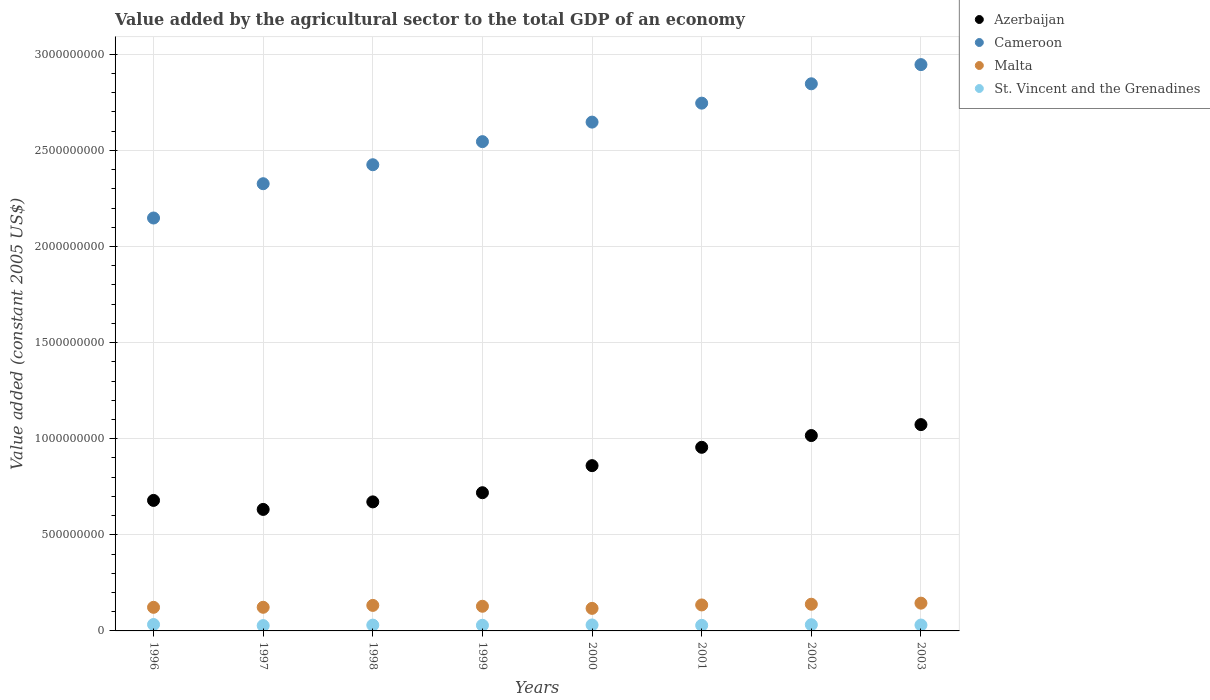How many different coloured dotlines are there?
Offer a terse response. 4. What is the value added by the agricultural sector in Cameroon in 2003?
Your answer should be very brief. 2.95e+09. Across all years, what is the maximum value added by the agricultural sector in Cameroon?
Your response must be concise. 2.95e+09. Across all years, what is the minimum value added by the agricultural sector in Azerbaijan?
Keep it short and to the point. 6.32e+08. In which year was the value added by the agricultural sector in St. Vincent and the Grenadines maximum?
Keep it short and to the point. 1996. In which year was the value added by the agricultural sector in Azerbaijan minimum?
Your answer should be very brief. 1997. What is the total value added by the agricultural sector in Azerbaijan in the graph?
Keep it short and to the point. 6.61e+09. What is the difference between the value added by the agricultural sector in St. Vincent and the Grenadines in 1999 and that in 2002?
Give a very brief answer. -2.91e+06. What is the difference between the value added by the agricultural sector in St. Vincent and the Grenadines in 2002 and the value added by the agricultural sector in Malta in 2003?
Ensure brevity in your answer.  -1.12e+08. What is the average value added by the agricultural sector in Azerbaijan per year?
Provide a succinct answer. 8.26e+08. In the year 1999, what is the difference between the value added by the agricultural sector in Cameroon and value added by the agricultural sector in St. Vincent and the Grenadines?
Offer a terse response. 2.52e+09. In how many years, is the value added by the agricultural sector in Malta greater than 900000000 US$?
Give a very brief answer. 0. What is the ratio of the value added by the agricultural sector in St. Vincent and the Grenadines in 1996 to that in 1999?
Your answer should be very brief. 1.14. Is the value added by the agricultural sector in Azerbaijan in 1998 less than that in 1999?
Make the answer very short. Yes. What is the difference between the highest and the second highest value added by the agricultural sector in Cameroon?
Your response must be concise. 9.97e+07. What is the difference between the highest and the lowest value added by the agricultural sector in Malta?
Ensure brevity in your answer.  2.71e+07. In how many years, is the value added by the agricultural sector in St. Vincent and the Grenadines greater than the average value added by the agricultural sector in St. Vincent and the Grenadines taken over all years?
Provide a succinct answer. 4. Is the sum of the value added by the agricultural sector in Cameroon in 1997 and 2001 greater than the maximum value added by the agricultural sector in Azerbaijan across all years?
Provide a succinct answer. Yes. Is it the case that in every year, the sum of the value added by the agricultural sector in St. Vincent and the Grenadines and value added by the agricultural sector in Malta  is greater than the value added by the agricultural sector in Azerbaijan?
Your answer should be compact. No. Does the value added by the agricultural sector in Cameroon monotonically increase over the years?
Ensure brevity in your answer.  Yes. Is the value added by the agricultural sector in St. Vincent and the Grenadines strictly greater than the value added by the agricultural sector in Azerbaijan over the years?
Provide a succinct answer. No. What is the difference between two consecutive major ticks on the Y-axis?
Offer a very short reply. 5.00e+08. Are the values on the major ticks of Y-axis written in scientific E-notation?
Offer a terse response. No. Does the graph contain any zero values?
Your answer should be very brief. No. Where does the legend appear in the graph?
Offer a terse response. Top right. What is the title of the graph?
Provide a short and direct response. Value added by the agricultural sector to the total GDP of an economy. What is the label or title of the Y-axis?
Your answer should be very brief. Value added (constant 2005 US$). What is the Value added (constant 2005 US$) in Azerbaijan in 1996?
Make the answer very short. 6.79e+08. What is the Value added (constant 2005 US$) in Cameroon in 1996?
Keep it short and to the point. 2.15e+09. What is the Value added (constant 2005 US$) in Malta in 1996?
Ensure brevity in your answer.  1.23e+08. What is the Value added (constant 2005 US$) in St. Vincent and the Grenadines in 1996?
Make the answer very short. 3.33e+07. What is the Value added (constant 2005 US$) of Azerbaijan in 1997?
Your answer should be compact. 6.32e+08. What is the Value added (constant 2005 US$) of Cameroon in 1997?
Provide a succinct answer. 2.33e+09. What is the Value added (constant 2005 US$) of Malta in 1997?
Provide a short and direct response. 1.23e+08. What is the Value added (constant 2005 US$) in St. Vincent and the Grenadines in 1997?
Keep it short and to the point. 2.77e+07. What is the Value added (constant 2005 US$) of Azerbaijan in 1998?
Ensure brevity in your answer.  6.71e+08. What is the Value added (constant 2005 US$) of Cameroon in 1998?
Your response must be concise. 2.43e+09. What is the Value added (constant 2005 US$) in Malta in 1998?
Give a very brief answer. 1.33e+08. What is the Value added (constant 2005 US$) in St. Vincent and the Grenadines in 1998?
Ensure brevity in your answer.  3.02e+07. What is the Value added (constant 2005 US$) of Azerbaijan in 1999?
Provide a succinct answer. 7.19e+08. What is the Value added (constant 2005 US$) of Cameroon in 1999?
Your response must be concise. 2.55e+09. What is the Value added (constant 2005 US$) in Malta in 1999?
Keep it short and to the point. 1.28e+08. What is the Value added (constant 2005 US$) of St. Vincent and the Grenadines in 1999?
Your answer should be very brief. 2.94e+07. What is the Value added (constant 2005 US$) in Azerbaijan in 2000?
Give a very brief answer. 8.60e+08. What is the Value added (constant 2005 US$) of Cameroon in 2000?
Offer a very short reply. 2.65e+09. What is the Value added (constant 2005 US$) of Malta in 2000?
Keep it short and to the point. 1.17e+08. What is the Value added (constant 2005 US$) of St. Vincent and the Grenadines in 2000?
Your answer should be very brief. 3.10e+07. What is the Value added (constant 2005 US$) of Azerbaijan in 2001?
Your answer should be very brief. 9.55e+08. What is the Value added (constant 2005 US$) of Cameroon in 2001?
Make the answer very short. 2.75e+09. What is the Value added (constant 2005 US$) in Malta in 2001?
Provide a succinct answer. 1.35e+08. What is the Value added (constant 2005 US$) of St. Vincent and the Grenadines in 2001?
Your answer should be compact. 2.89e+07. What is the Value added (constant 2005 US$) in Azerbaijan in 2002?
Provide a succinct answer. 1.02e+09. What is the Value added (constant 2005 US$) in Cameroon in 2002?
Provide a short and direct response. 2.85e+09. What is the Value added (constant 2005 US$) in Malta in 2002?
Your answer should be compact. 1.39e+08. What is the Value added (constant 2005 US$) in St. Vincent and the Grenadines in 2002?
Give a very brief answer. 3.23e+07. What is the Value added (constant 2005 US$) of Azerbaijan in 2003?
Provide a short and direct response. 1.07e+09. What is the Value added (constant 2005 US$) of Cameroon in 2003?
Ensure brevity in your answer.  2.95e+09. What is the Value added (constant 2005 US$) of Malta in 2003?
Provide a succinct answer. 1.44e+08. What is the Value added (constant 2005 US$) in St. Vincent and the Grenadines in 2003?
Your answer should be very brief. 3.06e+07. Across all years, what is the maximum Value added (constant 2005 US$) of Azerbaijan?
Ensure brevity in your answer.  1.07e+09. Across all years, what is the maximum Value added (constant 2005 US$) of Cameroon?
Your answer should be very brief. 2.95e+09. Across all years, what is the maximum Value added (constant 2005 US$) of Malta?
Ensure brevity in your answer.  1.44e+08. Across all years, what is the maximum Value added (constant 2005 US$) of St. Vincent and the Grenadines?
Provide a short and direct response. 3.33e+07. Across all years, what is the minimum Value added (constant 2005 US$) of Azerbaijan?
Keep it short and to the point. 6.32e+08. Across all years, what is the minimum Value added (constant 2005 US$) of Cameroon?
Your response must be concise. 2.15e+09. Across all years, what is the minimum Value added (constant 2005 US$) in Malta?
Your response must be concise. 1.17e+08. Across all years, what is the minimum Value added (constant 2005 US$) in St. Vincent and the Grenadines?
Your answer should be very brief. 2.77e+07. What is the total Value added (constant 2005 US$) of Azerbaijan in the graph?
Make the answer very short. 6.61e+09. What is the total Value added (constant 2005 US$) in Cameroon in the graph?
Offer a very short reply. 2.06e+1. What is the total Value added (constant 2005 US$) in Malta in the graph?
Offer a very short reply. 1.04e+09. What is the total Value added (constant 2005 US$) of St. Vincent and the Grenadines in the graph?
Make the answer very short. 2.43e+08. What is the difference between the Value added (constant 2005 US$) of Azerbaijan in 1996 and that in 1997?
Your response must be concise. 4.69e+07. What is the difference between the Value added (constant 2005 US$) of Cameroon in 1996 and that in 1997?
Your answer should be very brief. -1.78e+08. What is the difference between the Value added (constant 2005 US$) in Malta in 1996 and that in 1997?
Offer a terse response. -2.32e+05. What is the difference between the Value added (constant 2005 US$) of St. Vincent and the Grenadines in 1996 and that in 1997?
Offer a terse response. 5.68e+06. What is the difference between the Value added (constant 2005 US$) of Azerbaijan in 1996 and that in 1998?
Offer a very short reply. 7.66e+06. What is the difference between the Value added (constant 2005 US$) of Cameroon in 1996 and that in 1998?
Offer a very short reply. -2.77e+08. What is the difference between the Value added (constant 2005 US$) of Malta in 1996 and that in 1998?
Your answer should be compact. -1.00e+07. What is the difference between the Value added (constant 2005 US$) in St. Vincent and the Grenadines in 1996 and that in 1998?
Provide a succinct answer. 3.18e+06. What is the difference between the Value added (constant 2005 US$) of Azerbaijan in 1996 and that in 1999?
Keep it short and to the point. -4.00e+07. What is the difference between the Value added (constant 2005 US$) in Cameroon in 1996 and that in 1999?
Make the answer very short. -3.97e+08. What is the difference between the Value added (constant 2005 US$) in Malta in 1996 and that in 1999?
Keep it short and to the point. -5.55e+06. What is the difference between the Value added (constant 2005 US$) of St. Vincent and the Grenadines in 1996 and that in 1999?
Provide a short and direct response. 3.99e+06. What is the difference between the Value added (constant 2005 US$) of Azerbaijan in 1996 and that in 2000?
Make the answer very short. -1.81e+08. What is the difference between the Value added (constant 2005 US$) of Cameroon in 1996 and that in 2000?
Give a very brief answer. -4.99e+08. What is the difference between the Value added (constant 2005 US$) of Malta in 1996 and that in 2000?
Offer a very short reply. 5.41e+06. What is the difference between the Value added (constant 2005 US$) in St. Vincent and the Grenadines in 1996 and that in 2000?
Provide a short and direct response. 2.29e+06. What is the difference between the Value added (constant 2005 US$) in Azerbaijan in 1996 and that in 2001?
Provide a succinct answer. -2.76e+08. What is the difference between the Value added (constant 2005 US$) of Cameroon in 1996 and that in 2001?
Your answer should be compact. -5.98e+08. What is the difference between the Value added (constant 2005 US$) of Malta in 1996 and that in 2001?
Your answer should be compact. -1.24e+07. What is the difference between the Value added (constant 2005 US$) in St. Vincent and the Grenadines in 1996 and that in 2001?
Provide a short and direct response. 4.41e+06. What is the difference between the Value added (constant 2005 US$) of Azerbaijan in 1996 and that in 2002?
Provide a succinct answer. -3.37e+08. What is the difference between the Value added (constant 2005 US$) of Cameroon in 1996 and that in 2002?
Make the answer very short. -6.98e+08. What is the difference between the Value added (constant 2005 US$) in Malta in 1996 and that in 2002?
Provide a succinct answer. -1.61e+07. What is the difference between the Value added (constant 2005 US$) of St. Vincent and the Grenadines in 1996 and that in 2002?
Ensure brevity in your answer.  1.08e+06. What is the difference between the Value added (constant 2005 US$) of Azerbaijan in 1996 and that in 2003?
Your answer should be compact. -3.94e+08. What is the difference between the Value added (constant 2005 US$) in Cameroon in 1996 and that in 2003?
Ensure brevity in your answer.  -7.98e+08. What is the difference between the Value added (constant 2005 US$) of Malta in 1996 and that in 2003?
Offer a very short reply. -2.17e+07. What is the difference between the Value added (constant 2005 US$) of St. Vincent and the Grenadines in 1996 and that in 2003?
Your response must be concise. 2.71e+06. What is the difference between the Value added (constant 2005 US$) in Azerbaijan in 1997 and that in 1998?
Offer a very short reply. -3.92e+07. What is the difference between the Value added (constant 2005 US$) of Cameroon in 1997 and that in 1998?
Provide a short and direct response. -9.88e+07. What is the difference between the Value added (constant 2005 US$) in Malta in 1997 and that in 1998?
Give a very brief answer. -9.79e+06. What is the difference between the Value added (constant 2005 US$) in St. Vincent and the Grenadines in 1997 and that in 1998?
Give a very brief answer. -2.50e+06. What is the difference between the Value added (constant 2005 US$) of Azerbaijan in 1997 and that in 1999?
Your response must be concise. -8.69e+07. What is the difference between the Value added (constant 2005 US$) of Cameroon in 1997 and that in 1999?
Provide a succinct answer. -2.19e+08. What is the difference between the Value added (constant 2005 US$) in Malta in 1997 and that in 1999?
Your answer should be compact. -5.32e+06. What is the difference between the Value added (constant 2005 US$) of St. Vincent and the Grenadines in 1997 and that in 1999?
Make the answer very short. -1.69e+06. What is the difference between the Value added (constant 2005 US$) of Azerbaijan in 1997 and that in 2000?
Keep it short and to the point. -2.28e+08. What is the difference between the Value added (constant 2005 US$) in Cameroon in 1997 and that in 2000?
Provide a succinct answer. -3.21e+08. What is the difference between the Value added (constant 2005 US$) in Malta in 1997 and that in 2000?
Give a very brief answer. 5.64e+06. What is the difference between the Value added (constant 2005 US$) of St. Vincent and the Grenadines in 1997 and that in 2000?
Give a very brief answer. -3.38e+06. What is the difference between the Value added (constant 2005 US$) in Azerbaijan in 1997 and that in 2001?
Offer a very short reply. -3.23e+08. What is the difference between the Value added (constant 2005 US$) of Cameroon in 1997 and that in 2001?
Your answer should be compact. -4.19e+08. What is the difference between the Value added (constant 2005 US$) in Malta in 1997 and that in 2001?
Your answer should be very brief. -1.22e+07. What is the difference between the Value added (constant 2005 US$) of St. Vincent and the Grenadines in 1997 and that in 2001?
Provide a succinct answer. -1.27e+06. What is the difference between the Value added (constant 2005 US$) of Azerbaijan in 1997 and that in 2002?
Your answer should be compact. -3.84e+08. What is the difference between the Value added (constant 2005 US$) of Cameroon in 1997 and that in 2002?
Offer a terse response. -5.20e+08. What is the difference between the Value added (constant 2005 US$) in Malta in 1997 and that in 2002?
Your answer should be very brief. -1.59e+07. What is the difference between the Value added (constant 2005 US$) of St. Vincent and the Grenadines in 1997 and that in 2002?
Provide a short and direct response. -4.60e+06. What is the difference between the Value added (constant 2005 US$) of Azerbaijan in 1997 and that in 2003?
Keep it short and to the point. -4.41e+08. What is the difference between the Value added (constant 2005 US$) of Cameroon in 1997 and that in 2003?
Give a very brief answer. -6.20e+08. What is the difference between the Value added (constant 2005 US$) of Malta in 1997 and that in 2003?
Keep it short and to the point. -2.15e+07. What is the difference between the Value added (constant 2005 US$) in St. Vincent and the Grenadines in 1997 and that in 2003?
Your answer should be compact. -2.97e+06. What is the difference between the Value added (constant 2005 US$) in Azerbaijan in 1998 and that in 1999?
Keep it short and to the point. -4.77e+07. What is the difference between the Value added (constant 2005 US$) in Cameroon in 1998 and that in 1999?
Your answer should be compact. -1.20e+08. What is the difference between the Value added (constant 2005 US$) of Malta in 1998 and that in 1999?
Your answer should be very brief. 4.47e+06. What is the difference between the Value added (constant 2005 US$) of St. Vincent and the Grenadines in 1998 and that in 1999?
Keep it short and to the point. 8.10e+05. What is the difference between the Value added (constant 2005 US$) of Azerbaijan in 1998 and that in 2000?
Your answer should be very brief. -1.89e+08. What is the difference between the Value added (constant 2005 US$) in Cameroon in 1998 and that in 2000?
Ensure brevity in your answer.  -2.22e+08. What is the difference between the Value added (constant 2005 US$) in Malta in 1998 and that in 2000?
Make the answer very short. 1.54e+07. What is the difference between the Value added (constant 2005 US$) of St. Vincent and the Grenadines in 1998 and that in 2000?
Your answer should be compact. -8.86e+05. What is the difference between the Value added (constant 2005 US$) in Azerbaijan in 1998 and that in 2001?
Your answer should be very brief. -2.84e+08. What is the difference between the Value added (constant 2005 US$) of Cameroon in 1998 and that in 2001?
Keep it short and to the point. -3.20e+08. What is the difference between the Value added (constant 2005 US$) of Malta in 1998 and that in 2001?
Provide a short and direct response. -2.40e+06. What is the difference between the Value added (constant 2005 US$) in St. Vincent and the Grenadines in 1998 and that in 2001?
Keep it short and to the point. 1.23e+06. What is the difference between the Value added (constant 2005 US$) of Azerbaijan in 1998 and that in 2002?
Ensure brevity in your answer.  -3.45e+08. What is the difference between the Value added (constant 2005 US$) of Cameroon in 1998 and that in 2002?
Give a very brief answer. -4.21e+08. What is the difference between the Value added (constant 2005 US$) of Malta in 1998 and that in 2002?
Give a very brief answer. -6.11e+06. What is the difference between the Value added (constant 2005 US$) in St. Vincent and the Grenadines in 1998 and that in 2002?
Your response must be concise. -2.10e+06. What is the difference between the Value added (constant 2005 US$) in Azerbaijan in 1998 and that in 2003?
Provide a short and direct response. -4.02e+08. What is the difference between the Value added (constant 2005 US$) in Cameroon in 1998 and that in 2003?
Your response must be concise. -5.21e+08. What is the difference between the Value added (constant 2005 US$) of Malta in 1998 and that in 2003?
Keep it short and to the point. -1.17e+07. What is the difference between the Value added (constant 2005 US$) of St. Vincent and the Grenadines in 1998 and that in 2003?
Your answer should be very brief. -4.70e+05. What is the difference between the Value added (constant 2005 US$) in Azerbaijan in 1999 and that in 2000?
Offer a very short reply. -1.41e+08. What is the difference between the Value added (constant 2005 US$) of Cameroon in 1999 and that in 2000?
Make the answer very short. -1.02e+08. What is the difference between the Value added (constant 2005 US$) of Malta in 1999 and that in 2000?
Provide a succinct answer. 1.10e+07. What is the difference between the Value added (constant 2005 US$) of St. Vincent and the Grenadines in 1999 and that in 2000?
Your answer should be compact. -1.70e+06. What is the difference between the Value added (constant 2005 US$) in Azerbaijan in 1999 and that in 2001?
Give a very brief answer. -2.36e+08. What is the difference between the Value added (constant 2005 US$) of Cameroon in 1999 and that in 2001?
Keep it short and to the point. -2.00e+08. What is the difference between the Value added (constant 2005 US$) in Malta in 1999 and that in 2001?
Your response must be concise. -6.88e+06. What is the difference between the Value added (constant 2005 US$) of St. Vincent and the Grenadines in 1999 and that in 2001?
Your answer should be compact. 4.23e+05. What is the difference between the Value added (constant 2005 US$) in Azerbaijan in 1999 and that in 2002?
Make the answer very short. -2.97e+08. What is the difference between the Value added (constant 2005 US$) in Cameroon in 1999 and that in 2002?
Make the answer very short. -3.01e+08. What is the difference between the Value added (constant 2005 US$) of Malta in 1999 and that in 2002?
Your answer should be very brief. -1.06e+07. What is the difference between the Value added (constant 2005 US$) in St. Vincent and the Grenadines in 1999 and that in 2002?
Keep it short and to the point. -2.91e+06. What is the difference between the Value added (constant 2005 US$) in Azerbaijan in 1999 and that in 2003?
Provide a short and direct response. -3.54e+08. What is the difference between the Value added (constant 2005 US$) of Cameroon in 1999 and that in 2003?
Ensure brevity in your answer.  -4.01e+08. What is the difference between the Value added (constant 2005 US$) of Malta in 1999 and that in 2003?
Offer a terse response. -1.62e+07. What is the difference between the Value added (constant 2005 US$) of St. Vincent and the Grenadines in 1999 and that in 2003?
Your answer should be compact. -1.28e+06. What is the difference between the Value added (constant 2005 US$) in Azerbaijan in 2000 and that in 2001?
Your answer should be compact. -9.54e+07. What is the difference between the Value added (constant 2005 US$) in Cameroon in 2000 and that in 2001?
Keep it short and to the point. -9.86e+07. What is the difference between the Value added (constant 2005 US$) in Malta in 2000 and that in 2001?
Your response must be concise. -1.78e+07. What is the difference between the Value added (constant 2005 US$) of St. Vincent and the Grenadines in 2000 and that in 2001?
Provide a succinct answer. 2.12e+06. What is the difference between the Value added (constant 2005 US$) of Azerbaijan in 2000 and that in 2002?
Ensure brevity in your answer.  -1.57e+08. What is the difference between the Value added (constant 2005 US$) in Cameroon in 2000 and that in 2002?
Keep it short and to the point. -1.99e+08. What is the difference between the Value added (constant 2005 US$) of Malta in 2000 and that in 2002?
Provide a short and direct response. -2.15e+07. What is the difference between the Value added (constant 2005 US$) of St. Vincent and the Grenadines in 2000 and that in 2002?
Your answer should be compact. -1.21e+06. What is the difference between the Value added (constant 2005 US$) of Azerbaijan in 2000 and that in 2003?
Provide a succinct answer. -2.14e+08. What is the difference between the Value added (constant 2005 US$) in Cameroon in 2000 and that in 2003?
Your answer should be very brief. -2.99e+08. What is the difference between the Value added (constant 2005 US$) in Malta in 2000 and that in 2003?
Provide a short and direct response. -2.71e+07. What is the difference between the Value added (constant 2005 US$) in St. Vincent and the Grenadines in 2000 and that in 2003?
Your response must be concise. 4.16e+05. What is the difference between the Value added (constant 2005 US$) in Azerbaijan in 2001 and that in 2002?
Provide a succinct answer. -6.11e+07. What is the difference between the Value added (constant 2005 US$) of Cameroon in 2001 and that in 2002?
Your answer should be compact. -1.01e+08. What is the difference between the Value added (constant 2005 US$) in Malta in 2001 and that in 2002?
Provide a short and direct response. -3.71e+06. What is the difference between the Value added (constant 2005 US$) in St. Vincent and the Grenadines in 2001 and that in 2002?
Make the answer very short. -3.33e+06. What is the difference between the Value added (constant 2005 US$) in Azerbaijan in 2001 and that in 2003?
Give a very brief answer. -1.18e+08. What is the difference between the Value added (constant 2005 US$) in Cameroon in 2001 and that in 2003?
Offer a terse response. -2.00e+08. What is the difference between the Value added (constant 2005 US$) of Malta in 2001 and that in 2003?
Provide a short and direct response. -9.29e+06. What is the difference between the Value added (constant 2005 US$) in St. Vincent and the Grenadines in 2001 and that in 2003?
Your response must be concise. -1.70e+06. What is the difference between the Value added (constant 2005 US$) of Azerbaijan in 2002 and that in 2003?
Offer a very short reply. -5.69e+07. What is the difference between the Value added (constant 2005 US$) in Cameroon in 2002 and that in 2003?
Provide a succinct answer. -9.97e+07. What is the difference between the Value added (constant 2005 US$) in Malta in 2002 and that in 2003?
Offer a very short reply. -5.59e+06. What is the difference between the Value added (constant 2005 US$) of St. Vincent and the Grenadines in 2002 and that in 2003?
Ensure brevity in your answer.  1.63e+06. What is the difference between the Value added (constant 2005 US$) in Azerbaijan in 1996 and the Value added (constant 2005 US$) in Cameroon in 1997?
Offer a terse response. -1.65e+09. What is the difference between the Value added (constant 2005 US$) in Azerbaijan in 1996 and the Value added (constant 2005 US$) in Malta in 1997?
Offer a terse response. 5.56e+08. What is the difference between the Value added (constant 2005 US$) of Azerbaijan in 1996 and the Value added (constant 2005 US$) of St. Vincent and the Grenadines in 1997?
Make the answer very short. 6.51e+08. What is the difference between the Value added (constant 2005 US$) in Cameroon in 1996 and the Value added (constant 2005 US$) in Malta in 1997?
Provide a succinct answer. 2.03e+09. What is the difference between the Value added (constant 2005 US$) of Cameroon in 1996 and the Value added (constant 2005 US$) of St. Vincent and the Grenadines in 1997?
Your answer should be very brief. 2.12e+09. What is the difference between the Value added (constant 2005 US$) of Malta in 1996 and the Value added (constant 2005 US$) of St. Vincent and the Grenadines in 1997?
Ensure brevity in your answer.  9.51e+07. What is the difference between the Value added (constant 2005 US$) of Azerbaijan in 1996 and the Value added (constant 2005 US$) of Cameroon in 1998?
Offer a very short reply. -1.75e+09. What is the difference between the Value added (constant 2005 US$) of Azerbaijan in 1996 and the Value added (constant 2005 US$) of Malta in 1998?
Offer a very short reply. 5.46e+08. What is the difference between the Value added (constant 2005 US$) of Azerbaijan in 1996 and the Value added (constant 2005 US$) of St. Vincent and the Grenadines in 1998?
Ensure brevity in your answer.  6.49e+08. What is the difference between the Value added (constant 2005 US$) of Cameroon in 1996 and the Value added (constant 2005 US$) of Malta in 1998?
Offer a terse response. 2.02e+09. What is the difference between the Value added (constant 2005 US$) of Cameroon in 1996 and the Value added (constant 2005 US$) of St. Vincent and the Grenadines in 1998?
Provide a succinct answer. 2.12e+09. What is the difference between the Value added (constant 2005 US$) in Malta in 1996 and the Value added (constant 2005 US$) in St. Vincent and the Grenadines in 1998?
Provide a succinct answer. 9.26e+07. What is the difference between the Value added (constant 2005 US$) in Azerbaijan in 1996 and the Value added (constant 2005 US$) in Cameroon in 1999?
Offer a terse response. -1.87e+09. What is the difference between the Value added (constant 2005 US$) of Azerbaijan in 1996 and the Value added (constant 2005 US$) of Malta in 1999?
Provide a succinct answer. 5.51e+08. What is the difference between the Value added (constant 2005 US$) in Azerbaijan in 1996 and the Value added (constant 2005 US$) in St. Vincent and the Grenadines in 1999?
Ensure brevity in your answer.  6.50e+08. What is the difference between the Value added (constant 2005 US$) of Cameroon in 1996 and the Value added (constant 2005 US$) of Malta in 1999?
Give a very brief answer. 2.02e+09. What is the difference between the Value added (constant 2005 US$) of Cameroon in 1996 and the Value added (constant 2005 US$) of St. Vincent and the Grenadines in 1999?
Keep it short and to the point. 2.12e+09. What is the difference between the Value added (constant 2005 US$) in Malta in 1996 and the Value added (constant 2005 US$) in St. Vincent and the Grenadines in 1999?
Give a very brief answer. 9.34e+07. What is the difference between the Value added (constant 2005 US$) of Azerbaijan in 1996 and the Value added (constant 2005 US$) of Cameroon in 2000?
Provide a short and direct response. -1.97e+09. What is the difference between the Value added (constant 2005 US$) of Azerbaijan in 1996 and the Value added (constant 2005 US$) of Malta in 2000?
Provide a succinct answer. 5.62e+08. What is the difference between the Value added (constant 2005 US$) in Azerbaijan in 1996 and the Value added (constant 2005 US$) in St. Vincent and the Grenadines in 2000?
Your answer should be compact. 6.48e+08. What is the difference between the Value added (constant 2005 US$) in Cameroon in 1996 and the Value added (constant 2005 US$) in Malta in 2000?
Give a very brief answer. 2.03e+09. What is the difference between the Value added (constant 2005 US$) of Cameroon in 1996 and the Value added (constant 2005 US$) of St. Vincent and the Grenadines in 2000?
Ensure brevity in your answer.  2.12e+09. What is the difference between the Value added (constant 2005 US$) of Malta in 1996 and the Value added (constant 2005 US$) of St. Vincent and the Grenadines in 2000?
Give a very brief answer. 9.17e+07. What is the difference between the Value added (constant 2005 US$) of Azerbaijan in 1996 and the Value added (constant 2005 US$) of Cameroon in 2001?
Your answer should be compact. -2.07e+09. What is the difference between the Value added (constant 2005 US$) of Azerbaijan in 1996 and the Value added (constant 2005 US$) of Malta in 2001?
Ensure brevity in your answer.  5.44e+08. What is the difference between the Value added (constant 2005 US$) in Azerbaijan in 1996 and the Value added (constant 2005 US$) in St. Vincent and the Grenadines in 2001?
Give a very brief answer. 6.50e+08. What is the difference between the Value added (constant 2005 US$) of Cameroon in 1996 and the Value added (constant 2005 US$) of Malta in 2001?
Make the answer very short. 2.01e+09. What is the difference between the Value added (constant 2005 US$) in Cameroon in 1996 and the Value added (constant 2005 US$) in St. Vincent and the Grenadines in 2001?
Ensure brevity in your answer.  2.12e+09. What is the difference between the Value added (constant 2005 US$) in Malta in 1996 and the Value added (constant 2005 US$) in St. Vincent and the Grenadines in 2001?
Offer a very short reply. 9.38e+07. What is the difference between the Value added (constant 2005 US$) of Azerbaijan in 1996 and the Value added (constant 2005 US$) of Cameroon in 2002?
Make the answer very short. -2.17e+09. What is the difference between the Value added (constant 2005 US$) in Azerbaijan in 1996 and the Value added (constant 2005 US$) in Malta in 2002?
Your answer should be compact. 5.40e+08. What is the difference between the Value added (constant 2005 US$) of Azerbaijan in 1996 and the Value added (constant 2005 US$) of St. Vincent and the Grenadines in 2002?
Your answer should be very brief. 6.47e+08. What is the difference between the Value added (constant 2005 US$) in Cameroon in 1996 and the Value added (constant 2005 US$) in Malta in 2002?
Provide a short and direct response. 2.01e+09. What is the difference between the Value added (constant 2005 US$) of Cameroon in 1996 and the Value added (constant 2005 US$) of St. Vincent and the Grenadines in 2002?
Your answer should be compact. 2.12e+09. What is the difference between the Value added (constant 2005 US$) in Malta in 1996 and the Value added (constant 2005 US$) in St. Vincent and the Grenadines in 2002?
Ensure brevity in your answer.  9.05e+07. What is the difference between the Value added (constant 2005 US$) of Azerbaijan in 1996 and the Value added (constant 2005 US$) of Cameroon in 2003?
Make the answer very short. -2.27e+09. What is the difference between the Value added (constant 2005 US$) in Azerbaijan in 1996 and the Value added (constant 2005 US$) in Malta in 2003?
Your response must be concise. 5.35e+08. What is the difference between the Value added (constant 2005 US$) in Azerbaijan in 1996 and the Value added (constant 2005 US$) in St. Vincent and the Grenadines in 2003?
Give a very brief answer. 6.48e+08. What is the difference between the Value added (constant 2005 US$) of Cameroon in 1996 and the Value added (constant 2005 US$) of Malta in 2003?
Ensure brevity in your answer.  2.00e+09. What is the difference between the Value added (constant 2005 US$) in Cameroon in 1996 and the Value added (constant 2005 US$) in St. Vincent and the Grenadines in 2003?
Ensure brevity in your answer.  2.12e+09. What is the difference between the Value added (constant 2005 US$) of Malta in 1996 and the Value added (constant 2005 US$) of St. Vincent and the Grenadines in 2003?
Offer a very short reply. 9.21e+07. What is the difference between the Value added (constant 2005 US$) of Azerbaijan in 1997 and the Value added (constant 2005 US$) of Cameroon in 1998?
Make the answer very short. -1.79e+09. What is the difference between the Value added (constant 2005 US$) of Azerbaijan in 1997 and the Value added (constant 2005 US$) of Malta in 1998?
Your answer should be very brief. 4.99e+08. What is the difference between the Value added (constant 2005 US$) of Azerbaijan in 1997 and the Value added (constant 2005 US$) of St. Vincent and the Grenadines in 1998?
Your answer should be very brief. 6.02e+08. What is the difference between the Value added (constant 2005 US$) in Cameroon in 1997 and the Value added (constant 2005 US$) in Malta in 1998?
Give a very brief answer. 2.19e+09. What is the difference between the Value added (constant 2005 US$) in Cameroon in 1997 and the Value added (constant 2005 US$) in St. Vincent and the Grenadines in 1998?
Ensure brevity in your answer.  2.30e+09. What is the difference between the Value added (constant 2005 US$) in Malta in 1997 and the Value added (constant 2005 US$) in St. Vincent and the Grenadines in 1998?
Ensure brevity in your answer.  9.28e+07. What is the difference between the Value added (constant 2005 US$) in Azerbaijan in 1997 and the Value added (constant 2005 US$) in Cameroon in 1999?
Provide a succinct answer. -1.91e+09. What is the difference between the Value added (constant 2005 US$) in Azerbaijan in 1997 and the Value added (constant 2005 US$) in Malta in 1999?
Give a very brief answer. 5.04e+08. What is the difference between the Value added (constant 2005 US$) of Azerbaijan in 1997 and the Value added (constant 2005 US$) of St. Vincent and the Grenadines in 1999?
Offer a terse response. 6.03e+08. What is the difference between the Value added (constant 2005 US$) in Cameroon in 1997 and the Value added (constant 2005 US$) in Malta in 1999?
Offer a terse response. 2.20e+09. What is the difference between the Value added (constant 2005 US$) in Cameroon in 1997 and the Value added (constant 2005 US$) in St. Vincent and the Grenadines in 1999?
Give a very brief answer. 2.30e+09. What is the difference between the Value added (constant 2005 US$) in Malta in 1997 and the Value added (constant 2005 US$) in St. Vincent and the Grenadines in 1999?
Provide a succinct answer. 9.36e+07. What is the difference between the Value added (constant 2005 US$) of Azerbaijan in 1997 and the Value added (constant 2005 US$) of Cameroon in 2000?
Your answer should be compact. -2.02e+09. What is the difference between the Value added (constant 2005 US$) of Azerbaijan in 1997 and the Value added (constant 2005 US$) of Malta in 2000?
Offer a terse response. 5.15e+08. What is the difference between the Value added (constant 2005 US$) of Azerbaijan in 1997 and the Value added (constant 2005 US$) of St. Vincent and the Grenadines in 2000?
Your answer should be compact. 6.01e+08. What is the difference between the Value added (constant 2005 US$) in Cameroon in 1997 and the Value added (constant 2005 US$) in Malta in 2000?
Ensure brevity in your answer.  2.21e+09. What is the difference between the Value added (constant 2005 US$) in Cameroon in 1997 and the Value added (constant 2005 US$) in St. Vincent and the Grenadines in 2000?
Offer a terse response. 2.30e+09. What is the difference between the Value added (constant 2005 US$) in Malta in 1997 and the Value added (constant 2005 US$) in St. Vincent and the Grenadines in 2000?
Keep it short and to the point. 9.19e+07. What is the difference between the Value added (constant 2005 US$) in Azerbaijan in 1997 and the Value added (constant 2005 US$) in Cameroon in 2001?
Give a very brief answer. -2.11e+09. What is the difference between the Value added (constant 2005 US$) in Azerbaijan in 1997 and the Value added (constant 2005 US$) in Malta in 2001?
Give a very brief answer. 4.97e+08. What is the difference between the Value added (constant 2005 US$) in Azerbaijan in 1997 and the Value added (constant 2005 US$) in St. Vincent and the Grenadines in 2001?
Your answer should be very brief. 6.03e+08. What is the difference between the Value added (constant 2005 US$) of Cameroon in 1997 and the Value added (constant 2005 US$) of Malta in 2001?
Your answer should be very brief. 2.19e+09. What is the difference between the Value added (constant 2005 US$) in Cameroon in 1997 and the Value added (constant 2005 US$) in St. Vincent and the Grenadines in 2001?
Your answer should be compact. 2.30e+09. What is the difference between the Value added (constant 2005 US$) in Malta in 1997 and the Value added (constant 2005 US$) in St. Vincent and the Grenadines in 2001?
Give a very brief answer. 9.40e+07. What is the difference between the Value added (constant 2005 US$) in Azerbaijan in 1997 and the Value added (constant 2005 US$) in Cameroon in 2002?
Keep it short and to the point. -2.21e+09. What is the difference between the Value added (constant 2005 US$) in Azerbaijan in 1997 and the Value added (constant 2005 US$) in Malta in 2002?
Offer a very short reply. 4.93e+08. What is the difference between the Value added (constant 2005 US$) of Azerbaijan in 1997 and the Value added (constant 2005 US$) of St. Vincent and the Grenadines in 2002?
Offer a very short reply. 6.00e+08. What is the difference between the Value added (constant 2005 US$) in Cameroon in 1997 and the Value added (constant 2005 US$) in Malta in 2002?
Provide a short and direct response. 2.19e+09. What is the difference between the Value added (constant 2005 US$) of Cameroon in 1997 and the Value added (constant 2005 US$) of St. Vincent and the Grenadines in 2002?
Offer a terse response. 2.29e+09. What is the difference between the Value added (constant 2005 US$) in Malta in 1997 and the Value added (constant 2005 US$) in St. Vincent and the Grenadines in 2002?
Offer a terse response. 9.07e+07. What is the difference between the Value added (constant 2005 US$) of Azerbaijan in 1997 and the Value added (constant 2005 US$) of Cameroon in 2003?
Offer a terse response. -2.31e+09. What is the difference between the Value added (constant 2005 US$) in Azerbaijan in 1997 and the Value added (constant 2005 US$) in Malta in 2003?
Provide a succinct answer. 4.88e+08. What is the difference between the Value added (constant 2005 US$) in Azerbaijan in 1997 and the Value added (constant 2005 US$) in St. Vincent and the Grenadines in 2003?
Your answer should be compact. 6.02e+08. What is the difference between the Value added (constant 2005 US$) of Cameroon in 1997 and the Value added (constant 2005 US$) of Malta in 2003?
Your response must be concise. 2.18e+09. What is the difference between the Value added (constant 2005 US$) in Cameroon in 1997 and the Value added (constant 2005 US$) in St. Vincent and the Grenadines in 2003?
Offer a very short reply. 2.30e+09. What is the difference between the Value added (constant 2005 US$) in Malta in 1997 and the Value added (constant 2005 US$) in St. Vincent and the Grenadines in 2003?
Offer a terse response. 9.23e+07. What is the difference between the Value added (constant 2005 US$) in Azerbaijan in 1998 and the Value added (constant 2005 US$) in Cameroon in 1999?
Offer a very short reply. -1.87e+09. What is the difference between the Value added (constant 2005 US$) of Azerbaijan in 1998 and the Value added (constant 2005 US$) of Malta in 1999?
Your answer should be compact. 5.43e+08. What is the difference between the Value added (constant 2005 US$) in Azerbaijan in 1998 and the Value added (constant 2005 US$) in St. Vincent and the Grenadines in 1999?
Provide a succinct answer. 6.42e+08. What is the difference between the Value added (constant 2005 US$) of Cameroon in 1998 and the Value added (constant 2005 US$) of Malta in 1999?
Your answer should be compact. 2.30e+09. What is the difference between the Value added (constant 2005 US$) in Cameroon in 1998 and the Value added (constant 2005 US$) in St. Vincent and the Grenadines in 1999?
Ensure brevity in your answer.  2.40e+09. What is the difference between the Value added (constant 2005 US$) in Malta in 1998 and the Value added (constant 2005 US$) in St. Vincent and the Grenadines in 1999?
Your answer should be very brief. 1.03e+08. What is the difference between the Value added (constant 2005 US$) in Azerbaijan in 1998 and the Value added (constant 2005 US$) in Cameroon in 2000?
Your answer should be very brief. -1.98e+09. What is the difference between the Value added (constant 2005 US$) of Azerbaijan in 1998 and the Value added (constant 2005 US$) of Malta in 2000?
Offer a terse response. 5.54e+08. What is the difference between the Value added (constant 2005 US$) of Azerbaijan in 1998 and the Value added (constant 2005 US$) of St. Vincent and the Grenadines in 2000?
Ensure brevity in your answer.  6.40e+08. What is the difference between the Value added (constant 2005 US$) in Cameroon in 1998 and the Value added (constant 2005 US$) in Malta in 2000?
Offer a terse response. 2.31e+09. What is the difference between the Value added (constant 2005 US$) of Cameroon in 1998 and the Value added (constant 2005 US$) of St. Vincent and the Grenadines in 2000?
Provide a short and direct response. 2.39e+09. What is the difference between the Value added (constant 2005 US$) of Malta in 1998 and the Value added (constant 2005 US$) of St. Vincent and the Grenadines in 2000?
Keep it short and to the point. 1.02e+08. What is the difference between the Value added (constant 2005 US$) of Azerbaijan in 1998 and the Value added (constant 2005 US$) of Cameroon in 2001?
Provide a short and direct response. -2.07e+09. What is the difference between the Value added (constant 2005 US$) of Azerbaijan in 1998 and the Value added (constant 2005 US$) of Malta in 2001?
Provide a succinct answer. 5.36e+08. What is the difference between the Value added (constant 2005 US$) of Azerbaijan in 1998 and the Value added (constant 2005 US$) of St. Vincent and the Grenadines in 2001?
Offer a very short reply. 6.42e+08. What is the difference between the Value added (constant 2005 US$) of Cameroon in 1998 and the Value added (constant 2005 US$) of Malta in 2001?
Provide a short and direct response. 2.29e+09. What is the difference between the Value added (constant 2005 US$) of Cameroon in 1998 and the Value added (constant 2005 US$) of St. Vincent and the Grenadines in 2001?
Your response must be concise. 2.40e+09. What is the difference between the Value added (constant 2005 US$) of Malta in 1998 and the Value added (constant 2005 US$) of St. Vincent and the Grenadines in 2001?
Provide a succinct answer. 1.04e+08. What is the difference between the Value added (constant 2005 US$) in Azerbaijan in 1998 and the Value added (constant 2005 US$) in Cameroon in 2002?
Your response must be concise. -2.18e+09. What is the difference between the Value added (constant 2005 US$) in Azerbaijan in 1998 and the Value added (constant 2005 US$) in Malta in 2002?
Ensure brevity in your answer.  5.33e+08. What is the difference between the Value added (constant 2005 US$) in Azerbaijan in 1998 and the Value added (constant 2005 US$) in St. Vincent and the Grenadines in 2002?
Your response must be concise. 6.39e+08. What is the difference between the Value added (constant 2005 US$) in Cameroon in 1998 and the Value added (constant 2005 US$) in Malta in 2002?
Keep it short and to the point. 2.29e+09. What is the difference between the Value added (constant 2005 US$) in Cameroon in 1998 and the Value added (constant 2005 US$) in St. Vincent and the Grenadines in 2002?
Keep it short and to the point. 2.39e+09. What is the difference between the Value added (constant 2005 US$) in Malta in 1998 and the Value added (constant 2005 US$) in St. Vincent and the Grenadines in 2002?
Provide a succinct answer. 1.01e+08. What is the difference between the Value added (constant 2005 US$) of Azerbaijan in 1998 and the Value added (constant 2005 US$) of Cameroon in 2003?
Keep it short and to the point. -2.28e+09. What is the difference between the Value added (constant 2005 US$) in Azerbaijan in 1998 and the Value added (constant 2005 US$) in Malta in 2003?
Offer a terse response. 5.27e+08. What is the difference between the Value added (constant 2005 US$) in Azerbaijan in 1998 and the Value added (constant 2005 US$) in St. Vincent and the Grenadines in 2003?
Give a very brief answer. 6.41e+08. What is the difference between the Value added (constant 2005 US$) in Cameroon in 1998 and the Value added (constant 2005 US$) in Malta in 2003?
Make the answer very short. 2.28e+09. What is the difference between the Value added (constant 2005 US$) of Cameroon in 1998 and the Value added (constant 2005 US$) of St. Vincent and the Grenadines in 2003?
Offer a terse response. 2.39e+09. What is the difference between the Value added (constant 2005 US$) of Malta in 1998 and the Value added (constant 2005 US$) of St. Vincent and the Grenadines in 2003?
Make the answer very short. 1.02e+08. What is the difference between the Value added (constant 2005 US$) of Azerbaijan in 1999 and the Value added (constant 2005 US$) of Cameroon in 2000?
Your response must be concise. -1.93e+09. What is the difference between the Value added (constant 2005 US$) in Azerbaijan in 1999 and the Value added (constant 2005 US$) in Malta in 2000?
Offer a terse response. 6.02e+08. What is the difference between the Value added (constant 2005 US$) in Azerbaijan in 1999 and the Value added (constant 2005 US$) in St. Vincent and the Grenadines in 2000?
Ensure brevity in your answer.  6.88e+08. What is the difference between the Value added (constant 2005 US$) of Cameroon in 1999 and the Value added (constant 2005 US$) of Malta in 2000?
Provide a short and direct response. 2.43e+09. What is the difference between the Value added (constant 2005 US$) in Cameroon in 1999 and the Value added (constant 2005 US$) in St. Vincent and the Grenadines in 2000?
Offer a terse response. 2.51e+09. What is the difference between the Value added (constant 2005 US$) in Malta in 1999 and the Value added (constant 2005 US$) in St. Vincent and the Grenadines in 2000?
Offer a very short reply. 9.72e+07. What is the difference between the Value added (constant 2005 US$) in Azerbaijan in 1999 and the Value added (constant 2005 US$) in Cameroon in 2001?
Give a very brief answer. -2.03e+09. What is the difference between the Value added (constant 2005 US$) of Azerbaijan in 1999 and the Value added (constant 2005 US$) of Malta in 2001?
Provide a short and direct response. 5.84e+08. What is the difference between the Value added (constant 2005 US$) in Azerbaijan in 1999 and the Value added (constant 2005 US$) in St. Vincent and the Grenadines in 2001?
Provide a short and direct response. 6.90e+08. What is the difference between the Value added (constant 2005 US$) of Cameroon in 1999 and the Value added (constant 2005 US$) of Malta in 2001?
Provide a succinct answer. 2.41e+09. What is the difference between the Value added (constant 2005 US$) of Cameroon in 1999 and the Value added (constant 2005 US$) of St. Vincent and the Grenadines in 2001?
Give a very brief answer. 2.52e+09. What is the difference between the Value added (constant 2005 US$) of Malta in 1999 and the Value added (constant 2005 US$) of St. Vincent and the Grenadines in 2001?
Your answer should be very brief. 9.94e+07. What is the difference between the Value added (constant 2005 US$) of Azerbaijan in 1999 and the Value added (constant 2005 US$) of Cameroon in 2002?
Offer a very short reply. -2.13e+09. What is the difference between the Value added (constant 2005 US$) of Azerbaijan in 1999 and the Value added (constant 2005 US$) of Malta in 2002?
Your answer should be compact. 5.80e+08. What is the difference between the Value added (constant 2005 US$) in Azerbaijan in 1999 and the Value added (constant 2005 US$) in St. Vincent and the Grenadines in 2002?
Offer a very short reply. 6.87e+08. What is the difference between the Value added (constant 2005 US$) in Cameroon in 1999 and the Value added (constant 2005 US$) in Malta in 2002?
Your answer should be very brief. 2.41e+09. What is the difference between the Value added (constant 2005 US$) of Cameroon in 1999 and the Value added (constant 2005 US$) of St. Vincent and the Grenadines in 2002?
Your answer should be very brief. 2.51e+09. What is the difference between the Value added (constant 2005 US$) of Malta in 1999 and the Value added (constant 2005 US$) of St. Vincent and the Grenadines in 2002?
Provide a short and direct response. 9.60e+07. What is the difference between the Value added (constant 2005 US$) in Azerbaijan in 1999 and the Value added (constant 2005 US$) in Cameroon in 2003?
Provide a succinct answer. -2.23e+09. What is the difference between the Value added (constant 2005 US$) in Azerbaijan in 1999 and the Value added (constant 2005 US$) in Malta in 2003?
Provide a short and direct response. 5.75e+08. What is the difference between the Value added (constant 2005 US$) of Azerbaijan in 1999 and the Value added (constant 2005 US$) of St. Vincent and the Grenadines in 2003?
Ensure brevity in your answer.  6.88e+08. What is the difference between the Value added (constant 2005 US$) in Cameroon in 1999 and the Value added (constant 2005 US$) in Malta in 2003?
Provide a short and direct response. 2.40e+09. What is the difference between the Value added (constant 2005 US$) of Cameroon in 1999 and the Value added (constant 2005 US$) of St. Vincent and the Grenadines in 2003?
Make the answer very short. 2.52e+09. What is the difference between the Value added (constant 2005 US$) in Malta in 1999 and the Value added (constant 2005 US$) in St. Vincent and the Grenadines in 2003?
Offer a very short reply. 9.77e+07. What is the difference between the Value added (constant 2005 US$) in Azerbaijan in 2000 and the Value added (constant 2005 US$) in Cameroon in 2001?
Your answer should be compact. -1.89e+09. What is the difference between the Value added (constant 2005 US$) of Azerbaijan in 2000 and the Value added (constant 2005 US$) of Malta in 2001?
Keep it short and to the point. 7.25e+08. What is the difference between the Value added (constant 2005 US$) in Azerbaijan in 2000 and the Value added (constant 2005 US$) in St. Vincent and the Grenadines in 2001?
Your response must be concise. 8.31e+08. What is the difference between the Value added (constant 2005 US$) in Cameroon in 2000 and the Value added (constant 2005 US$) in Malta in 2001?
Your answer should be very brief. 2.51e+09. What is the difference between the Value added (constant 2005 US$) of Cameroon in 2000 and the Value added (constant 2005 US$) of St. Vincent and the Grenadines in 2001?
Make the answer very short. 2.62e+09. What is the difference between the Value added (constant 2005 US$) of Malta in 2000 and the Value added (constant 2005 US$) of St. Vincent and the Grenadines in 2001?
Keep it short and to the point. 8.84e+07. What is the difference between the Value added (constant 2005 US$) of Azerbaijan in 2000 and the Value added (constant 2005 US$) of Cameroon in 2002?
Make the answer very short. -1.99e+09. What is the difference between the Value added (constant 2005 US$) in Azerbaijan in 2000 and the Value added (constant 2005 US$) in Malta in 2002?
Provide a short and direct response. 7.21e+08. What is the difference between the Value added (constant 2005 US$) of Azerbaijan in 2000 and the Value added (constant 2005 US$) of St. Vincent and the Grenadines in 2002?
Ensure brevity in your answer.  8.28e+08. What is the difference between the Value added (constant 2005 US$) in Cameroon in 2000 and the Value added (constant 2005 US$) in Malta in 2002?
Offer a terse response. 2.51e+09. What is the difference between the Value added (constant 2005 US$) in Cameroon in 2000 and the Value added (constant 2005 US$) in St. Vincent and the Grenadines in 2002?
Offer a very short reply. 2.62e+09. What is the difference between the Value added (constant 2005 US$) of Malta in 2000 and the Value added (constant 2005 US$) of St. Vincent and the Grenadines in 2002?
Your answer should be very brief. 8.51e+07. What is the difference between the Value added (constant 2005 US$) in Azerbaijan in 2000 and the Value added (constant 2005 US$) in Cameroon in 2003?
Make the answer very short. -2.09e+09. What is the difference between the Value added (constant 2005 US$) of Azerbaijan in 2000 and the Value added (constant 2005 US$) of Malta in 2003?
Your response must be concise. 7.15e+08. What is the difference between the Value added (constant 2005 US$) in Azerbaijan in 2000 and the Value added (constant 2005 US$) in St. Vincent and the Grenadines in 2003?
Make the answer very short. 8.29e+08. What is the difference between the Value added (constant 2005 US$) of Cameroon in 2000 and the Value added (constant 2005 US$) of Malta in 2003?
Your response must be concise. 2.50e+09. What is the difference between the Value added (constant 2005 US$) of Cameroon in 2000 and the Value added (constant 2005 US$) of St. Vincent and the Grenadines in 2003?
Your answer should be very brief. 2.62e+09. What is the difference between the Value added (constant 2005 US$) in Malta in 2000 and the Value added (constant 2005 US$) in St. Vincent and the Grenadines in 2003?
Ensure brevity in your answer.  8.67e+07. What is the difference between the Value added (constant 2005 US$) of Azerbaijan in 2001 and the Value added (constant 2005 US$) of Cameroon in 2002?
Ensure brevity in your answer.  -1.89e+09. What is the difference between the Value added (constant 2005 US$) in Azerbaijan in 2001 and the Value added (constant 2005 US$) in Malta in 2002?
Make the answer very short. 8.16e+08. What is the difference between the Value added (constant 2005 US$) in Azerbaijan in 2001 and the Value added (constant 2005 US$) in St. Vincent and the Grenadines in 2002?
Offer a very short reply. 9.23e+08. What is the difference between the Value added (constant 2005 US$) of Cameroon in 2001 and the Value added (constant 2005 US$) of Malta in 2002?
Keep it short and to the point. 2.61e+09. What is the difference between the Value added (constant 2005 US$) of Cameroon in 2001 and the Value added (constant 2005 US$) of St. Vincent and the Grenadines in 2002?
Your answer should be very brief. 2.71e+09. What is the difference between the Value added (constant 2005 US$) in Malta in 2001 and the Value added (constant 2005 US$) in St. Vincent and the Grenadines in 2002?
Make the answer very short. 1.03e+08. What is the difference between the Value added (constant 2005 US$) of Azerbaijan in 2001 and the Value added (constant 2005 US$) of Cameroon in 2003?
Ensure brevity in your answer.  -1.99e+09. What is the difference between the Value added (constant 2005 US$) in Azerbaijan in 2001 and the Value added (constant 2005 US$) in Malta in 2003?
Your answer should be very brief. 8.11e+08. What is the difference between the Value added (constant 2005 US$) of Azerbaijan in 2001 and the Value added (constant 2005 US$) of St. Vincent and the Grenadines in 2003?
Offer a terse response. 9.25e+08. What is the difference between the Value added (constant 2005 US$) in Cameroon in 2001 and the Value added (constant 2005 US$) in Malta in 2003?
Give a very brief answer. 2.60e+09. What is the difference between the Value added (constant 2005 US$) of Cameroon in 2001 and the Value added (constant 2005 US$) of St. Vincent and the Grenadines in 2003?
Provide a short and direct response. 2.72e+09. What is the difference between the Value added (constant 2005 US$) of Malta in 2001 and the Value added (constant 2005 US$) of St. Vincent and the Grenadines in 2003?
Give a very brief answer. 1.05e+08. What is the difference between the Value added (constant 2005 US$) of Azerbaijan in 2002 and the Value added (constant 2005 US$) of Cameroon in 2003?
Offer a terse response. -1.93e+09. What is the difference between the Value added (constant 2005 US$) of Azerbaijan in 2002 and the Value added (constant 2005 US$) of Malta in 2003?
Offer a very short reply. 8.72e+08. What is the difference between the Value added (constant 2005 US$) in Azerbaijan in 2002 and the Value added (constant 2005 US$) in St. Vincent and the Grenadines in 2003?
Your response must be concise. 9.86e+08. What is the difference between the Value added (constant 2005 US$) of Cameroon in 2002 and the Value added (constant 2005 US$) of Malta in 2003?
Ensure brevity in your answer.  2.70e+09. What is the difference between the Value added (constant 2005 US$) in Cameroon in 2002 and the Value added (constant 2005 US$) in St. Vincent and the Grenadines in 2003?
Your response must be concise. 2.82e+09. What is the difference between the Value added (constant 2005 US$) in Malta in 2002 and the Value added (constant 2005 US$) in St. Vincent and the Grenadines in 2003?
Give a very brief answer. 1.08e+08. What is the average Value added (constant 2005 US$) in Azerbaijan per year?
Give a very brief answer. 8.26e+08. What is the average Value added (constant 2005 US$) of Cameroon per year?
Offer a very short reply. 2.58e+09. What is the average Value added (constant 2005 US$) of Malta per year?
Ensure brevity in your answer.  1.30e+08. What is the average Value added (constant 2005 US$) in St. Vincent and the Grenadines per year?
Your answer should be very brief. 3.04e+07. In the year 1996, what is the difference between the Value added (constant 2005 US$) in Azerbaijan and Value added (constant 2005 US$) in Cameroon?
Your answer should be very brief. -1.47e+09. In the year 1996, what is the difference between the Value added (constant 2005 US$) of Azerbaijan and Value added (constant 2005 US$) of Malta?
Keep it short and to the point. 5.56e+08. In the year 1996, what is the difference between the Value added (constant 2005 US$) of Azerbaijan and Value added (constant 2005 US$) of St. Vincent and the Grenadines?
Your response must be concise. 6.46e+08. In the year 1996, what is the difference between the Value added (constant 2005 US$) of Cameroon and Value added (constant 2005 US$) of Malta?
Your answer should be compact. 2.03e+09. In the year 1996, what is the difference between the Value added (constant 2005 US$) in Cameroon and Value added (constant 2005 US$) in St. Vincent and the Grenadines?
Ensure brevity in your answer.  2.12e+09. In the year 1996, what is the difference between the Value added (constant 2005 US$) of Malta and Value added (constant 2005 US$) of St. Vincent and the Grenadines?
Your answer should be very brief. 8.94e+07. In the year 1997, what is the difference between the Value added (constant 2005 US$) in Azerbaijan and Value added (constant 2005 US$) in Cameroon?
Offer a very short reply. -1.69e+09. In the year 1997, what is the difference between the Value added (constant 2005 US$) of Azerbaijan and Value added (constant 2005 US$) of Malta?
Provide a short and direct response. 5.09e+08. In the year 1997, what is the difference between the Value added (constant 2005 US$) of Azerbaijan and Value added (constant 2005 US$) of St. Vincent and the Grenadines?
Your answer should be compact. 6.05e+08. In the year 1997, what is the difference between the Value added (constant 2005 US$) in Cameroon and Value added (constant 2005 US$) in Malta?
Your response must be concise. 2.20e+09. In the year 1997, what is the difference between the Value added (constant 2005 US$) in Cameroon and Value added (constant 2005 US$) in St. Vincent and the Grenadines?
Offer a terse response. 2.30e+09. In the year 1997, what is the difference between the Value added (constant 2005 US$) of Malta and Value added (constant 2005 US$) of St. Vincent and the Grenadines?
Ensure brevity in your answer.  9.53e+07. In the year 1998, what is the difference between the Value added (constant 2005 US$) of Azerbaijan and Value added (constant 2005 US$) of Cameroon?
Ensure brevity in your answer.  -1.75e+09. In the year 1998, what is the difference between the Value added (constant 2005 US$) in Azerbaijan and Value added (constant 2005 US$) in Malta?
Give a very brief answer. 5.39e+08. In the year 1998, what is the difference between the Value added (constant 2005 US$) of Azerbaijan and Value added (constant 2005 US$) of St. Vincent and the Grenadines?
Make the answer very short. 6.41e+08. In the year 1998, what is the difference between the Value added (constant 2005 US$) of Cameroon and Value added (constant 2005 US$) of Malta?
Ensure brevity in your answer.  2.29e+09. In the year 1998, what is the difference between the Value added (constant 2005 US$) of Cameroon and Value added (constant 2005 US$) of St. Vincent and the Grenadines?
Your answer should be compact. 2.40e+09. In the year 1998, what is the difference between the Value added (constant 2005 US$) in Malta and Value added (constant 2005 US$) in St. Vincent and the Grenadines?
Your answer should be compact. 1.03e+08. In the year 1999, what is the difference between the Value added (constant 2005 US$) in Azerbaijan and Value added (constant 2005 US$) in Cameroon?
Ensure brevity in your answer.  -1.83e+09. In the year 1999, what is the difference between the Value added (constant 2005 US$) in Azerbaijan and Value added (constant 2005 US$) in Malta?
Give a very brief answer. 5.91e+08. In the year 1999, what is the difference between the Value added (constant 2005 US$) in Azerbaijan and Value added (constant 2005 US$) in St. Vincent and the Grenadines?
Give a very brief answer. 6.90e+08. In the year 1999, what is the difference between the Value added (constant 2005 US$) of Cameroon and Value added (constant 2005 US$) of Malta?
Provide a short and direct response. 2.42e+09. In the year 1999, what is the difference between the Value added (constant 2005 US$) in Cameroon and Value added (constant 2005 US$) in St. Vincent and the Grenadines?
Provide a short and direct response. 2.52e+09. In the year 1999, what is the difference between the Value added (constant 2005 US$) in Malta and Value added (constant 2005 US$) in St. Vincent and the Grenadines?
Provide a short and direct response. 9.89e+07. In the year 2000, what is the difference between the Value added (constant 2005 US$) of Azerbaijan and Value added (constant 2005 US$) of Cameroon?
Provide a short and direct response. -1.79e+09. In the year 2000, what is the difference between the Value added (constant 2005 US$) of Azerbaijan and Value added (constant 2005 US$) of Malta?
Provide a short and direct response. 7.43e+08. In the year 2000, what is the difference between the Value added (constant 2005 US$) in Azerbaijan and Value added (constant 2005 US$) in St. Vincent and the Grenadines?
Your answer should be very brief. 8.29e+08. In the year 2000, what is the difference between the Value added (constant 2005 US$) of Cameroon and Value added (constant 2005 US$) of Malta?
Provide a short and direct response. 2.53e+09. In the year 2000, what is the difference between the Value added (constant 2005 US$) of Cameroon and Value added (constant 2005 US$) of St. Vincent and the Grenadines?
Keep it short and to the point. 2.62e+09. In the year 2000, what is the difference between the Value added (constant 2005 US$) in Malta and Value added (constant 2005 US$) in St. Vincent and the Grenadines?
Provide a succinct answer. 8.63e+07. In the year 2001, what is the difference between the Value added (constant 2005 US$) of Azerbaijan and Value added (constant 2005 US$) of Cameroon?
Your answer should be very brief. -1.79e+09. In the year 2001, what is the difference between the Value added (constant 2005 US$) in Azerbaijan and Value added (constant 2005 US$) in Malta?
Your response must be concise. 8.20e+08. In the year 2001, what is the difference between the Value added (constant 2005 US$) of Azerbaijan and Value added (constant 2005 US$) of St. Vincent and the Grenadines?
Your answer should be very brief. 9.26e+08. In the year 2001, what is the difference between the Value added (constant 2005 US$) in Cameroon and Value added (constant 2005 US$) in Malta?
Your answer should be very brief. 2.61e+09. In the year 2001, what is the difference between the Value added (constant 2005 US$) of Cameroon and Value added (constant 2005 US$) of St. Vincent and the Grenadines?
Make the answer very short. 2.72e+09. In the year 2001, what is the difference between the Value added (constant 2005 US$) in Malta and Value added (constant 2005 US$) in St. Vincent and the Grenadines?
Keep it short and to the point. 1.06e+08. In the year 2002, what is the difference between the Value added (constant 2005 US$) in Azerbaijan and Value added (constant 2005 US$) in Cameroon?
Offer a terse response. -1.83e+09. In the year 2002, what is the difference between the Value added (constant 2005 US$) of Azerbaijan and Value added (constant 2005 US$) of Malta?
Ensure brevity in your answer.  8.78e+08. In the year 2002, what is the difference between the Value added (constant 2005 US$) in Azerbaijan and Value added (constant 2005 US$) in St. Vincent and the Grenadines?
Your answer should be very brief. 9.84e+08. In the year 2002, what is the difference between the Value added (constant 2005 US$) of Cameroon and Value added (constant 2005 US$) of Malta?
Offer a terse response. 2.71e+09. In the year 2002, what is the difference between the Value added (constant 2005 US$) in Cameroon and Value added (constant 2005 US$) in St. Vincent and the Grenadines?
Provide a succinct answer. 2.81e+09. In the year 2002, what is the difference between the Value added (constant 2005 US$) of Malta and Value added (constant 2005 US$) of St. Vincent and the Grenadines?
Offer a very short reply. 1.07e+08. In the year 2003, what is the difference between the Value added (constant 2005 US$) of Azerbaijan and Value added (constant 2005 US$) of Cameroon?
Your answer should be very brief. -1.87e+09. In the year 2003, what is the difference between the Value added (constant 2005 US$) of Azerbaijan and Value added (constant 2005 US$) of Malta?
Offer a terse response. 9.29e+08. In the year 2003, what is the difference between the Value added (constant 2005 US$) in Azerbaijan and Value added (constant 2005 US$) in St. Vincent and the Grenadines?
Your answer should be compact. 1.04e+09. In the year 2003, what is the difference between the Value added (constant 2005 US$) of Cameroon and Value added (constant 2005 US$) of Malta?
Your answer should be compact. 2.80e+09. In the year 2003, what is the difference between the Value added (constant 2005 US$) in Cameroon and Value added (constant 2005 US$) in St. Vincent and the Grenadines?
Make the answer very short. 2.92e+09. In the year 2003, what is the difference between the Value added (constant 2005 US$) of Malta and Value added (constant 2005 US$) of St. Vincent and the Grenadines?
Offer a terse response. 1.14e+08. What is the ratio of the Value added (constant 2005 US$) in Azerbaijan in 1996 to that in 1997?
Your response must be concise. 1.07. What is the ratio of the Value added (constant 2005 US$) in Cameroon in 1996 to that in 1997?
Give a very brief answer. 0.92. What is the ratio of the Value added (constant 2005 US$) of St. Vincent and the Grenadines in 1996 to that in 1997?
Make the answer very short. 1.21. What is the ratio of the Value added (constant 2005 US$) in Azerbaijan in 1996 to that in 1998?
Offer a very short reply. 1.01. What is the ratio of the Value added (constant 2005 US$) of Cameroon in 1996 to that in 1998?
Your answer should be compact. 0.89. What is the ratio of the Value added (constant 2005 US$) of Malta in 1996 to that in 1998?
Keep it short and to the point. 0.92. What is the ratio of the Value added (constant 2005 US$) of St. Vincent and the Grenadines in 1996 to that in 1998?
Offer a terse response. 1.11. What is the ratio of the Value added (constant 2005 US$) of Azerbaijan in 1996 to that in 1999?
Your answer should be very brief. 0.94. What is the ratio of the Value added (constant 2005 US$) in Cameroon in 1996 to that in 1999?
Provide a succinct answer. 0.84. What is the ratio of the Value added (constant 2005 US$) of Malta in 1996 to that in 1999?
Your answer should be compact. 0.96. What is the ratio of the Value added (constant 2005 US$) in St. Vincent and the Grenadines in 1996 to that in 1999?
Make the answer very short. 1.14. What is the ratio of the Value added (constant 2005 US$) of Azerbaijan in 1996 to that in 2000?
Offer a terse response. 0.79. What is the ratio of the Value added (constant 2005 US$) of Cameroon in 1996 to that in 2000?
Your answer should be compact. 0.81. What is the ratio of the Value added (constant 2005 US$) in Malta in 1996 to that in 2000?
Offer a terse response. 1.05. What is the ratio of the Value added (constant 2005 US$) in St. Vincent and the Grenadines in 1996 to that in 2000?
Provide a succinct answer. 1.07. What is the ratio of the Value added (constant 2005 US$) of Azerbaijan in 1996 to that in 2001?
Your answer should be very brief. 0.71. What is the ratio of the Value added (constant 2005 US$) in Cameroon in 1996 to that in 2001?
Your answer should be very brief. 0.78. What is the ratio of the Value added (constant 2005 US$) of Malta in 1996 to that in 2001?
Your answer should be very brief. 0.91. What is the ratio of the Value added (constant 2005 US$) in St. Vincent and the Grenadines in 1996 to that in 2001?
Provide a short and direct response. 1.15. What is the ratio of the Value added (constant 2005 US$) in Azerbaijan in 1996 to that in 2002?
Offer a very short reply. 0.67. What is the ratio of the Value added (constant 2005 US$) in Cameroon in 1996 to that in 2002?
Provide a succinct answer. 0.75. What is the ratio of the Value added (constant 2005 US$) of Malta in 1996 to that in 2002?
Ensure brevity in your answer.  0.88. What is the ratio of the Value added (constant 2005 US$) of St. Vincent and the Grenadines in 1996 to that in 2002?
Ensure brevity in your answer.  1.03. What is the ratio of the Value added (constant 2005 US$) in Azerbaijan in 1996 to that in 2003?
Give a very brief answer. 0.63. What is the ratio of the Value added (constant 2005 US$) of Cameroon in 1996 to that in 2003?
Your answer should be compact. 0.73. What is the ratio of the Value added (constant 2005 US$) of Malta in 1996 to that in 2003?
Provide a succinct answer. 0.85. What is the ratio of the Value added (constant 2005 US$) of St. Vincent and the Grenadines in 1996 to that in 2003?
Keep it short and to the point. 1.09. What is the ratio of the Value added (constant 2005 US$) of Azerbaijan in 1997 to that in 1998?
Your answer should be compact. 0.94. What is the ratio of the Value added (constant 2005 US$) of Cameroon in 1997 to that in 1998?
Your answer should be compact. 0.96. What is the ratio of the Value added (constant 2005 US$) in Malta in 1997 to that in 1998?
Provide a short and direct response. 0.93. What is the ratio of the Value added (constant 2005 US$) of St. Vincent and the Grenadines in 1997 to that in 1998?
Offer a terse response. 0.92. What is the ratio of the Value added (constant 2005 US$) of Azerbaijan in 1997 to that in 1999?
Your answer should be compact. 0.88. What is the ratio of the Value added (constant 2005 US$) of Cameroon in 1997 to that in 1999?
Keep it short and to the point. 0.91. What is the ratio of the Value added (constant 2005 US$) in Malta in 1997 to that in 1999?
Offer a terse response. 0.96. What is the ratio of the Value added (constant 2005 US$) of St. Vincent and the Grenadines in 1997 to that in 1999?
Ensure brevity in your answer.  0.94. What is the ratio of the Value added (constant 2005 US$) in Azerbaijan in 1997 to that in 2000?
Your answer should be very brief. 0.74. What is the ratio of the Value added (constant 2005 US$) in Cameroon in 1997 to that in 2000?
Offer a very short reply. 0.88. What is the ratio of the Value added (constant 2005 US$) of Malta in 1997 to that in 2000?
Keep it short and to the point. 1.05. What is the ratio of the Value added (constant 2005 US$) in St. Vincent and the Grenadines in 1997 to that in 2000?
Make the answer very short. 0.89. What is the ratio of the Value added (constant 2005 US$) in Azerbaijan in 1997 to that in 2001?
Your response must be concise. 0.66. What is the ratio of the Value added (constant 2005 US$) in Cameroon in 1997 to that in 2001?
Offer a very short reply. 0.85. What is the ratio of the Value added (constant 2005 US$) of Malta in 1997 to that in 2001?
Your answer should be very brief. 0.91. What is the ratio of the Value added (constant 2005 US$) in St. Vincent and the Grenadines in 1997 to that in 2001?
Your answer should be very brief. 0.96. What is the ratio of the Value added (constant 2005 US$) of Azerbaijan in 1997 to that in 2002?
Offer a very short reply. 0.62. What is the ratio of the Value added (constant 2005 US$) in Cameroon in 1997 to that in 2002?
Offer a terse response. 0.82. What is the ratio of the Value added (constant 2005 US$) of Malta in 1997 to that in 2002?
Offer a very short reply. 0.89. What is the ratio of the Value added (constant 2005 US$) in St. Vincent and the Grenadines in 1997 to that in 2002?
Provide a short and direct response. 0.86. What is the ratio of the Value added (constant 2005 US$) in Azerbaijan in 1997 to that in 2003?
Offer a terse response. 0.59. What is the ratio of the Value added (constant 2005 US$) of Cameroon in 1997 to that in 2003?
Offer a very short reply. 0.79. What is the ratio of the Value added (constant 2005 US$) of Malta in 1997 to that in 2003?
Give a very brief answer. 0.85. What is the ratio of the Value added (constant 2005 US$) in St. Vincent and the Grenadines in 1997 to that in 2003?
Your answer should be very brief. 0.9. What is the ratio of the Value added (constant 2005 US$) in Azerbaijan in 1998 to that in 1999?
Provide a succinct answer. 0.93. What is the ratio of the Value added (constant 2005 US$) of Cameroon in 1998 to that in 1999?
Provide a succinct answer. 0.95. What is the ratio of the Value added (constant 2005 US$) in Malta in 1998 to that in 1999?
Give a very brief answer. 1.03. What is the ratio of the Value added (constant 2005 US$) in St. Vincent and the Grenadines in 1998 to that in 1999?
Provide a succinct answer. 1.03. What is the ratio of the Value added (constant 2005 US$) of Azerbaijan in 1998 to that in 2000?
Your answer should be compact. 0.78. What is the ratio of the Value added (constant 2005 US$) in Cameroon in 1998 to that in 2000?
Provide a succinct answer. 0.92. What is the ratio of the Value added (constant 2005 US$) in Malta in 1998 to that in 2000?
Your answer should be very brief. 1.13. What is the ratio of the Value added (constant 2005 US$) of St. Vincent and the Grenadines in 1998 to that in 2000?
Offer a very short reply. 0.97. What is the ratio of the Value added (constant 2005 US$) of Azerbaijan in 1998 to that in 2001?
Provide a short and direct response. 0.7. What is the ratio of the Value added (constant 2005 US$) in Cameroon in 1998 to that in 2001?
Keep it short and to the point. 0.88. What is the ratio of the Value added (constant 2005 US$) of Malta in 1998 to that in 2001?
Offer a terse response. 0.98. What is the ratio of the Value added (constant 2005 US$) in St. Vincent and the Grenadines in 1998 to that in 2001?
Make the answer very short. 1.04. What is the ratio of the Value added (constant 2005 US$) of Azerbaijan in 1998 to that in 2002?
Provide a succinct answer. 0.66. What is the ratio of the Value added (constant 2005 US$) in Cameroon in 1998 to that in 2002?
Ensure brevity in your answer.  0.85. What is the ratio of the Value added (constant 2005 US$) of Malta in 1998 to that in 2002?
Give a very brief answer. 0.96. What is the ratio of the Value added (constant 2005 US$) in St. Vincent and the Grenadines in 1998 to that in 2002?
Your answer should be very brief. 0.93. What is the ratio of the Value added (constant 2005 US$) of Azerbaijan in 1998 to that in 2003?
Ensure brevity in your answer.  0.63. What is the ratio of the Value added (constant 2005 US$) in Cameroon in 1998 to that in 2003?
Offer a terse response. 0.82. What is the ratio of the Value added (constant 2005 US$) of Malta in 1998 to that in 2003?
Make the answer very short. 0.92. What is the ratio of the Value added (constant 2005 US$) of St. Vincent and the Grenadines in 1998 to that in 2003?
Make the answer very short. 0.98. What is the ratio of the Value added (constant 2005 US$) in Azerbaijan in 1999 to that in 2000?
Offer a terse response. 0.84. What is the ratio of the Value added (constant 2005 US$) in Cameroon in 1999 to that in 2000?
Your answer should be compact. 0.96. What is the ratio of the Value added (constant 2005 US$) of Malta in 1999 to that in 2000?
Offer a very short reply. 1.09. What is the ratio of the Value added (constant 2005 US$) of St. Vincent and the Grenadines in 1999 to that in 2000?
Provide a succinct answer. 0.95. What is the ratio of the Value added (constant 2005 US$) of Azerbaijan in 1999 to that in 2001?
Ensure brevity in your answer.  0.75. What is the ratio of the Value added (constant 2005 US$) of Cameroon in 1999 to that in 2001?
Offer a very short reply. 0.93. What is the ratio of the Value added (constant 2005 US$) of Malta in 1999 to that in 2001?
Offer a terse response. 0.95. What is the ratio of the Value added (constant 2005 US$) in St. Vincent and the Grenadines in 1999 to that in 2001?
Offer a terse response. 1.01. What is the ratio of the Value added (constant 2005 US$) in Azerbaijan in 1999 to that in 2002?
Offer a terse response. 0.71. What is the ratio of the Value added (constant 2005 US$) of Cameroon in 1999 to that in 2002?
Give a very brief answer. 0.89. What is the ratio of the Value added (constant 2005 US$) in Malta in 1999 to that in 2002?
Offer a terse response. 0.92. What is the ratio of the Value added (constant 2005 US$) of St. Vincent and the Grenadines in 1999 to that in 2002?
Your response must be concise. 0.91. What is the ratio of the Value added (constant 2005 US$) in Azerbaijan in 1999 to that in 2003?
Provide a short and direct response. 0.67. What is the ratio of the Value added (constant 2005 US$) in Cameroon in 1999 to that in 2003?
Make the answer very short. 0.86. What is the ratio of the Value added (constant 2005 US$) of Malta in 1999 to that in 2003?
Your answer should be compact. 0.89. What is the ratio of the Value added (constant 2005 US$) in St. Vincent and the Grenadines in 1999 to that in 2003?
Provide a short and direct response. 0.96. What is the ratio of the Value added (constant 2005 US$) in Azerbaijan in 2000 to that in 2001?
Ensure brevity in your answer.  0.9. What is the ratio of the Value added (constant 2005 US$) of Cameroon in 2000 to that in 2001?
Offer a very short reply. 0.96. What is the ratio of the Value added (constant 2005 US$) of Malta in 2000 to that in 2001?
Offer a very short reply. 0.87. What is the ratio of the Value added (constant 2005 US$) in St. Vincent and the Grenadines in 2000 to that in 2001?
Your answer should be very brief. 1.07. What is the ratio of the Value added (constant 2005 US$) in Azerbaijan in 2000 to that in 2002?
Offer a terse response. 0.85. What is the ratio of the Value added (constant 2005 US$) in Malta in 2000 to that in 2002?
Offer a very short reply. 0.84. What is the ratio of the Value added (constant 2005 US$) of St. Vincent and the Grenadines in 2000 to that in 2002?
Ensure brevity in your answer.  0.96. What is the ratio of the Value added (constant 2005 US$) of Azerbaijan in 2000 to that in 2003?
Provide a short and direct response. 0.8. What is the ratio of the Value added (constant 2005 US$) of Cameroon in 2000 to that in 2003?
Keep it short and to the point. 0.9. What is the ratio of the Value added (constant 2005 US$) of Malta in 2000 to that in 2003?
Your response must be concise. 0.81. What is the ratio of the Value added (constant 2005 US$) of St. Vincent and the Grenadines in 2000 to that in 2003?
Give a very brief answer. 1.01. What is the ratio of the Value added (constant 2005 US$) in Azerbaijan in 2001 to that in 2002?
Provide a short and direct response. 0.94. What is the ratio of the Value added (constant 2005 US$) of Cameroon in 2001 to that in 2002?
Ensure brevity in your answer.  0.96. What is the ratio of the Value added (constant 2005 US$) in Malta in 2001 to that in 2002?
Offer a terse response. 0.97. What is the ratio of the Value added (constant 2005 US$) of St. Vincent and the Grenadines in 2001 to that in 2002?
Provide a succinct answer. 0.9. What is the ratio of the Value added (constant 2005 US$) in Azerbaijan in 2001 to that in 2003?
Offer a terse response. 0.89. What is the ratio of the Value added (constant 2005 US$) in Cameroon in 2001 to that in 2003?
Provide a succinct answer. 0.93. What is the ratio of the Value added (constant 2005 US$) in Malta in 2001 to that in 2003?
Provide a succinct answer. 0.94. What is the ratio of the Value added (constant 2005 US$) of St. Vincent and the Grenadines in 2001 to that in 2003?
Offer a terse response. 0.94. What is the ratio of the Value added (constant 2005 US$) of Azerbaijan in 2002 to that in 2003?
Keep it short and to the point. 0.95. What is the ratio of the Value added (constant 2005 US$) of Cameroon in 2002 to that in 2003?
Your response must be concise. 0.97. What is the ratio of the Value added (constant 2005 US$) in Malta in 2002 to that in 2003?
Provide a succinct answer. 0.96. What is the ratio of the Value added (constant 2005 US$) of St. Vincent and the Grenadines in 2002 to that in 2003?
Keep it short and to the point. 1.05. What is the difference between the highest and the second highest Value added (constant 2005 US$) in Azerbaijan?
Your answer should be very brief. 5.69e+07. What is the difference between the highest and the second highest Value added (constant 2005 US$) of Cameroon?
Offer a terse response. 9.97e+07. What is the difference between the highest and the second highest Value added (constant 2005 US$) in Malta?
Your response must be concise. 5.59e+06. What is the difference between the highest and the second highest Value added (constant 2005 US$) in St. Vincent and the Grenadines?
Keep it short and to the point. 1.08e+06. What is the difference between the highest and the lowest Value added (constant 2005 US$) in Azerbaijan?
Keep it short and to the point. 4.41e+08. What is the difference between the highest and the lowest Value added (constant 2005 US$) in Cameroon?
Provide a succinct answer. 7.98e+08. What is the difference between the highest and the lowest Value added (constant 2005 US$) of Malta?
Provide a succinct answer. 2.71e+07. What is the difference between the highest and the lowest Value added (constant 2005 US$) of St. Vincent and the Grenadines?
Ensure brevity in your answer.  5.68e+06. 